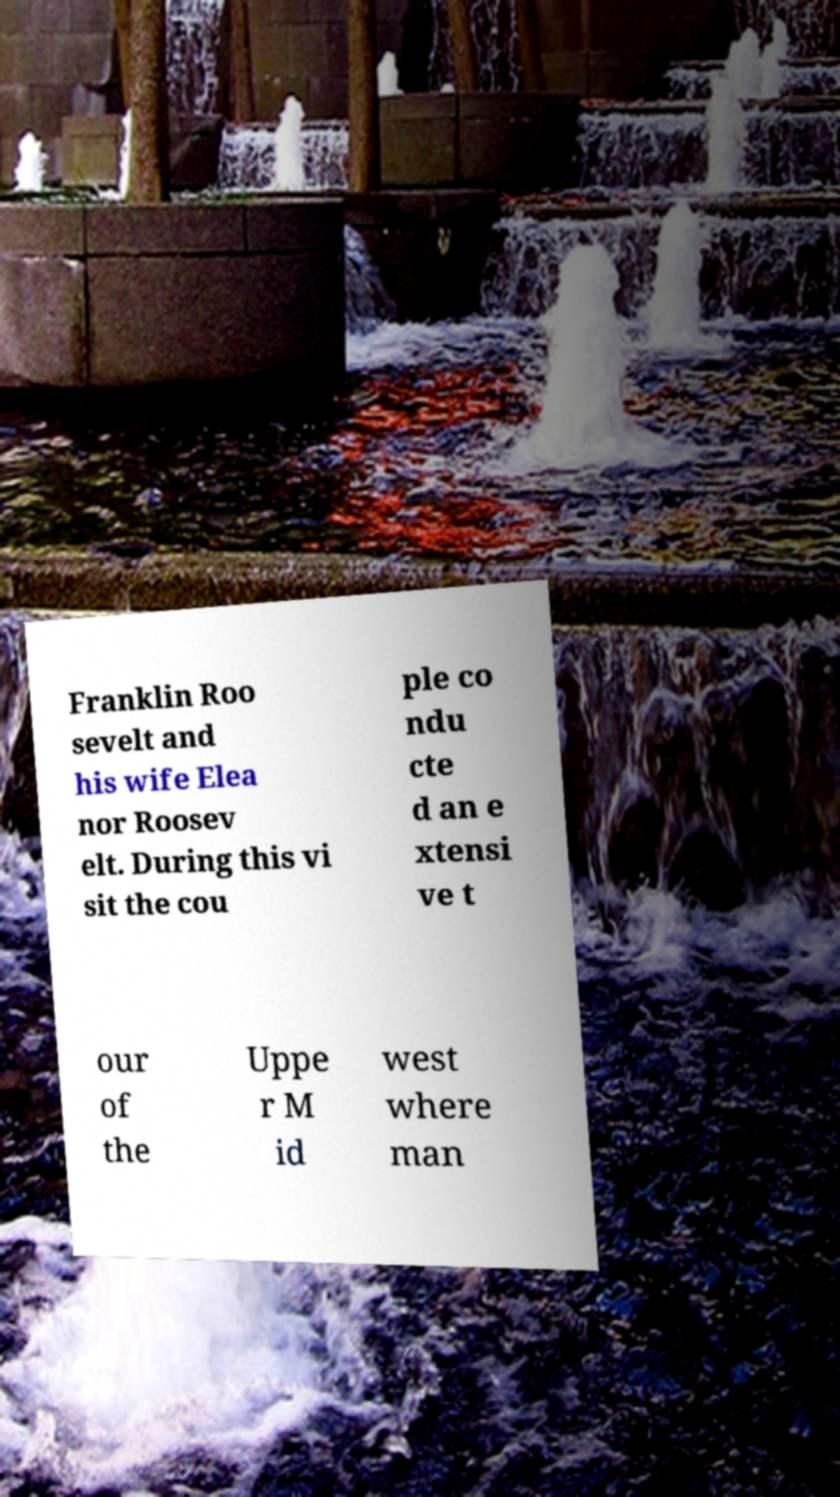Please identify and transcribe the text found in this image. Franklin Roo sevelt and his wife Elea nor Roosev elt. During this vi sit the cou ple co ndu cte d an e xtensi ve t our of the Uppe r M id west where man 